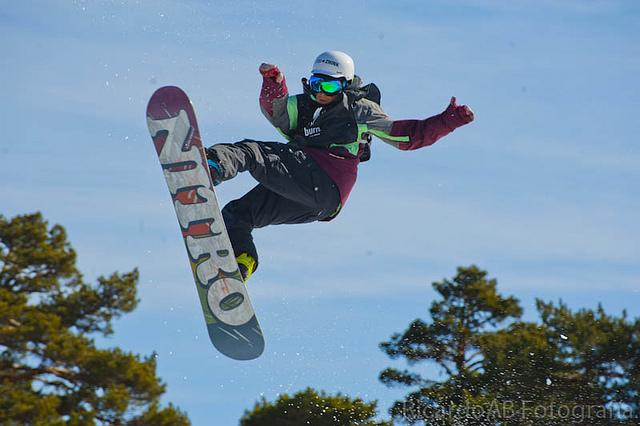Is the snowboarder wearing goggles?
Keep it brief. Yes. Is this person nervous?
Short answer required. No. What brand is the snowboard?
Concise answer only. Nitro. 